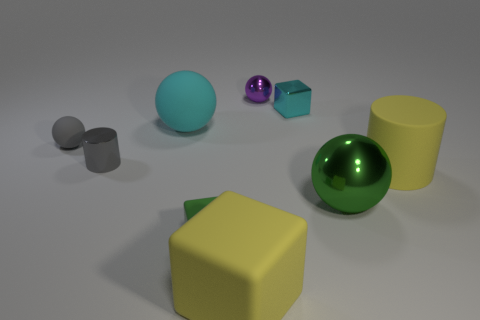What number of things are tiny green cylinders or green things?
Provide a succinct answer. 2. How many yellow cylinders have the same material as the tiny green cube?
Keep it short and to the point. 1. What is the size of the cyan metal object that is the same shape as the small green rubber object?
Keep it short and to the point. Small. Are there any small matte things in front of the large yellow block?
Ensure brevity in your answer.  No. What is the material of the yellow cylinder?
Give a very brief answer. Rubber. There is a cylinder in front of the small gray metallic cylinder; is it the same color as the large cube?
Give a very brief answer. Yes. What is the color of the other tiny metal object that is the same shape as the small green thing?
Ensure brevity in your answer.  Cyan. There is a cyan object on the right side of the tiny green cube; what is its material?
Your answer should be compact. Metal. The tiny metal cylinder is what color?
Offer a very short reply. Gray. There is a metal object that is on the right side of the cyan metallic cube; is its size the same as the gray metallic thing?
Offer a terse response. No. 